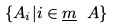<formula> <loc_0><loc_0><loc_500><loc_500>\{ A _ { i } | i \in \underline { m } \ A \}</formula> 